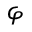<formula> <loc_0><loc_0><loc_500><loc_500>\varphi</formula> 